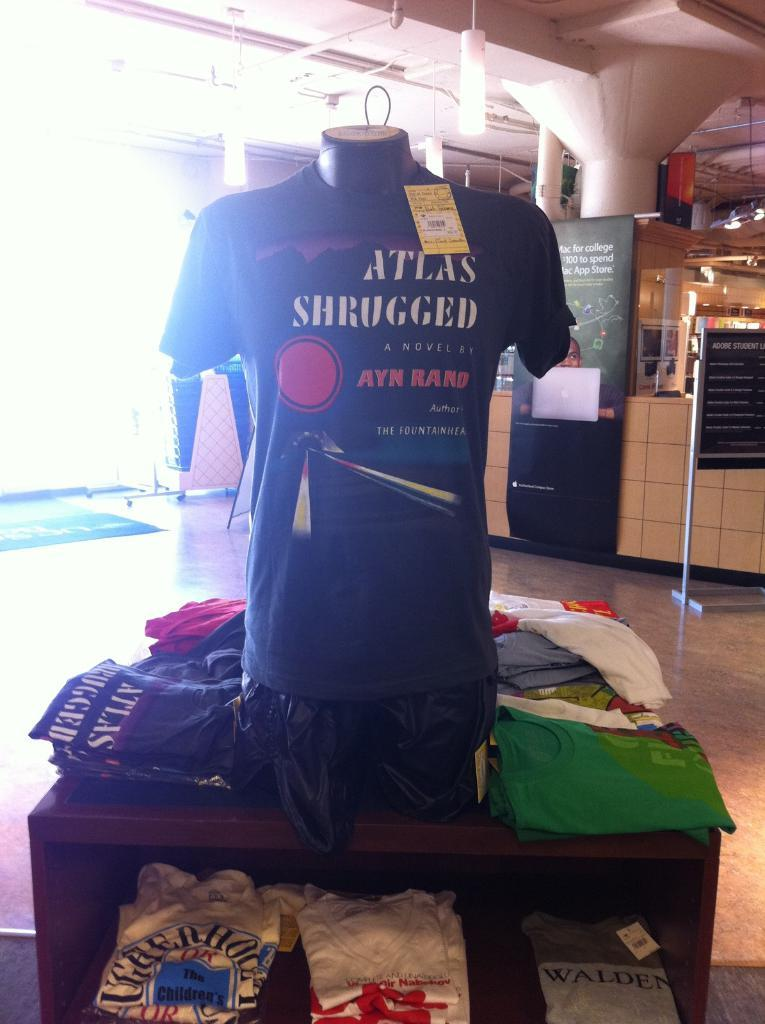<image>
Offer a succinct explanation of the picture presented. A t-shirt for Ayn Rand's Atlas Shrugged is displayed on a mannequin chest. 